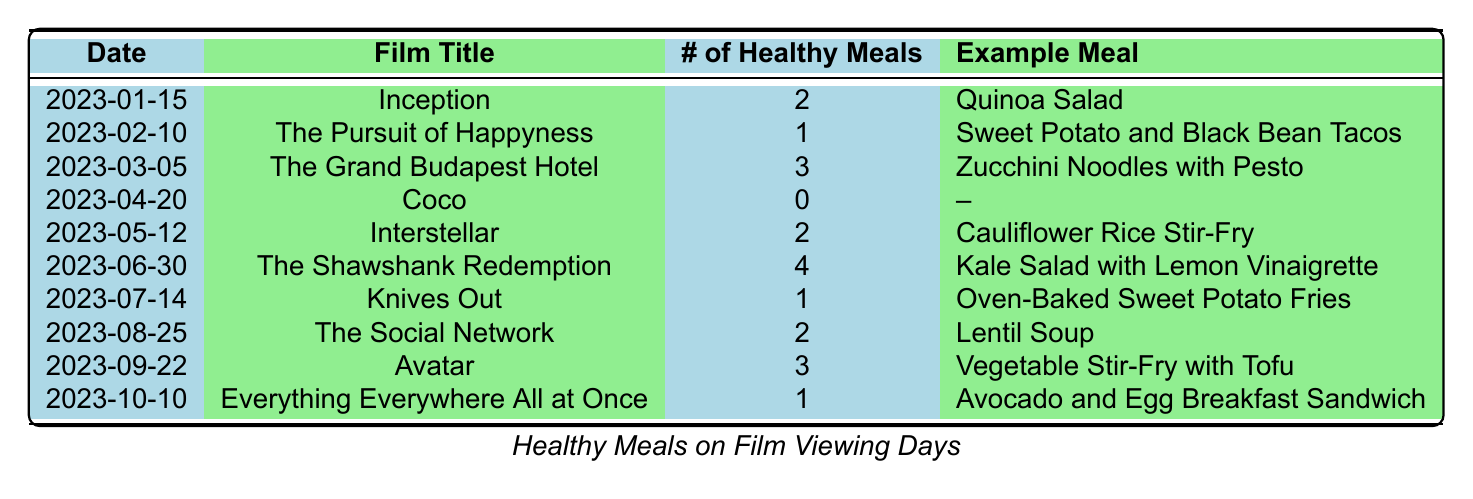What film viewing day had the highest number of healthy meals prepared? Looking at the table, "The Shawshank Redemption" on 2023-06-30 had the highest number of healthy meals prepared, which is 4.
Answer: 2023-06-30 How many healthy meals were prepared in total across all film viewing days? By summing the healthy meals from each entry: 2 + 1 + 3 + 0 + 2 + 4 + 1 + 2 + 3 + 1 = 19.
Answer: 19 Did any film viewing days have no healthy meals prepared? Yes, "Coco" on 2023-04-20 had 0 healthy meals prepared.
Answer: Yes What is the average number of healthy meals prepared per film viewing day? There are 10 film viewing days and the total number of healthy meals is 19. So, the average is 19 / 10 = 1.9.
Answer: 1.9 How many more healthy meals were prepared on "The Shawshank Redemption" compared to "Knives Out"? "The Shawshank Redemption" had 4 healthy meals and "Knives Out" had 1, so 4 - 1 = 3 more healthy meals.
Answer: 3 more Which film had the fewest healthy meals prepared, and what was the meal? "Coco" had the fewest healthy meals prepared, which was 0, and there were no example meals listed.
Answer: Coco How many films had 2 healthy meals prepared? There are three film viewing days with 2 healthy meals prepared: "Inception," "Interstellar," and "The Social Network.".
Answer: 3 films What percentage of the film viewing days had at least 2 healthy meals prepared? There are 7 film viewing days with at least 2 healthy meals (adding those with 2, 3, or 4 meals: Inception, The Grand Budapest Hotel, Interstellar, The Shawshank Redemption, The Social Network, and Avatar). Thus, 7 out of 10 days gives us (7/10)*100 = 70%.
Answer: 70% What is the most common healthy meal prepared on film viewing days? The meals prepared varied, and no meal appeared more than once, making it impossible to determine a most common meal from the provided data.
Answer: No common meal 